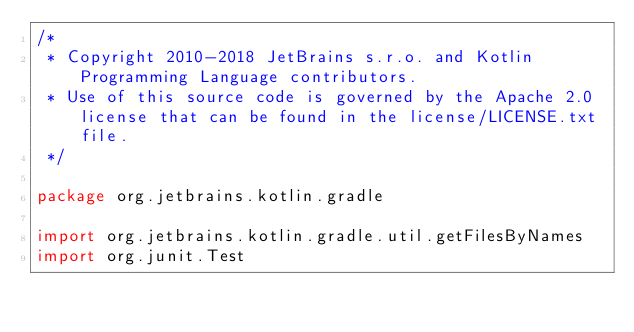<code> <loc_0><loc_0><loc_500><loc_500><_Kotlin_>/*
 * Copyright 2010-2018 JetBrains s.r.o. and Kotlin Programming Language contributors.
 * Use of this source code is governed by the Apache 2.0 license that can be found in the license/LICENSE.txt file.
 */

package org.jetbrains.kotlin.gradle

import org.jetbrains.kotlin.gradle.util.getFilesByNames
import org.junit.Test</code> 